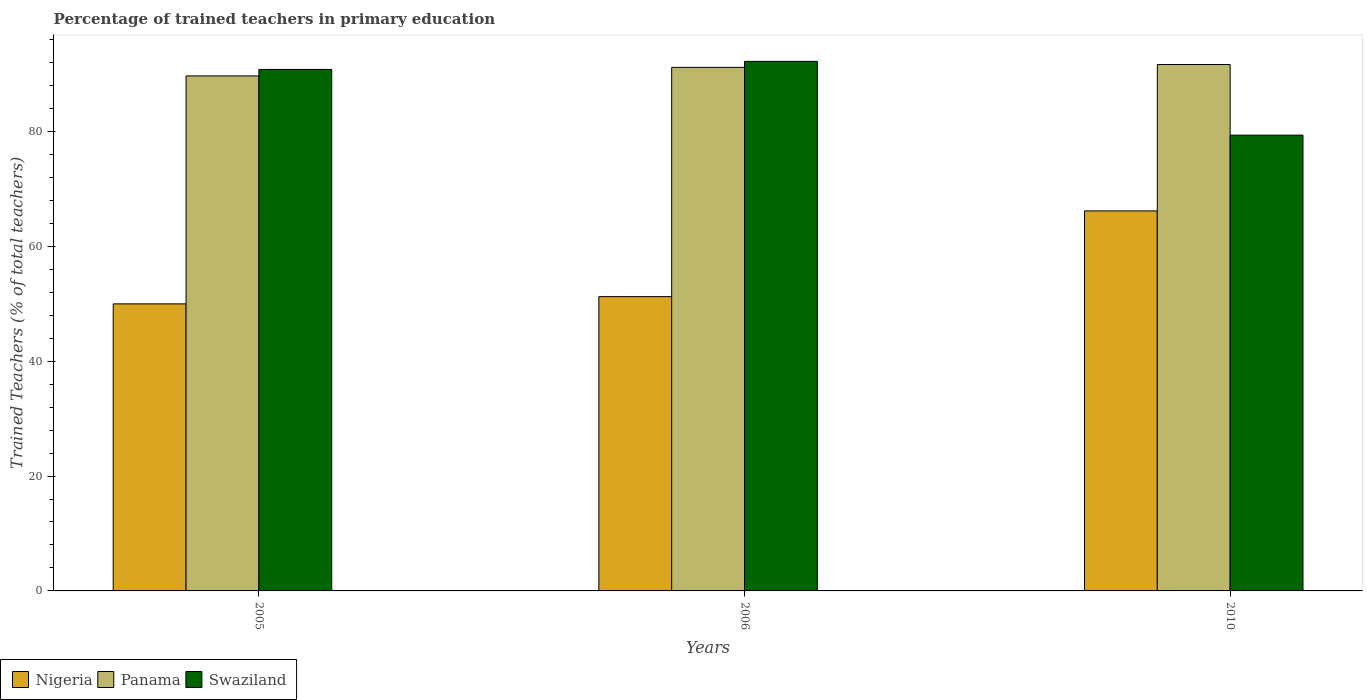How many different coloured bars are there?
Offer a terse response. 3. How many groups of bars are there?
Make the answer very short. 3. Are the number of bars per tick equal to the number of legend labels?
Offer a terse response. Yes. Are the number of bars on each tick of the X-axis equal?
Provide a succinct answer. Yes. How many bars are there on the 2nd tick from the right?
Keep it short and to the point. 3. What is the label of the 2nd group of bars from the left?
Provide a short and direct response. 2006. What is the percentage of trained teachers in Panama in 2005?
Your response must be concise. 89.65. Across all years, what is the maximum percentage of trained teachers in Swaziland?
Offer a very short reply. 92.18. Across all years, what is the minimum percentage of trained teachers in Nigeria?
Provide a short and direct response. 49.97. In which year was the percentage of trained teachers in Panama maximum?
Your answer should be very brief. 2010. What is the total percentage of trained teachers in Panama in the graph?
Provide a short and direct response. 272.41. What is the difference between the percentage of trained teachers in Nigeria in 2005 and that in 2010?
Make the answer very short. -16.18. What is the difference between the percentage of trained teachers in Nigeria in 2005 and the percentage of trained teachers in Panama in 2006?
Give a very brief answer. -41.17. What is the average percentage of trained teachers in Panama per year?
Make the answer very short. 90.8. In the year 2006, what is the difference between the percentage of trained teachers in Nigeria and percentage of trained teachers in Swaziland?
Your response must be concise. -40.96. In how many years, is the percentage of trained teachers in Panama greater than 80 %?
Give a very brief answer. 3. What is the ratio of the percentage of trained teachers in Nigeria in 2006 to that in 2010?
Your response must be concise. 0.77. Is the difference between the percentage of trained teachers in Nigeria in 2005 and 2010 greater than the difference between the percentage of trained teachers in Swaziland in 2005 and 2010?
Make the answer very short. No. What is the difference between the highest and the second highest percentage of trained teachers in Panama?
Provide a short and direct response. 0.5. What is the difference between the highest and the lowest percentage of trained teachers in Swaziland?
Give a very brief answer. 12.84. In how many years, is the percentage of trained teachers in Swaziland greater than the average percentage of trained teachers in Swaziland taken over all years?
Provide a succinct answer. 2. What does the 3rd bar from the left in 2005 represents?
Make the answer very short. Swaziland. What does the 2nd bar from the right in 2010 represents?
Ensure brevity in your answer.  Panama. Are all the bars in the graph horizontal?
Your answer should be very brief. No. What is the difference between two consecutive major ticks on the Y-axis?
Offer a very short reply. 20. Are the values on the major ticks of Y-axis written in scientific E-notation?
Provide a succinct answer. No. How many legend labels are there?
Your response must be concise. 3. How are the legend labels stacked?
Your response must be concise. Horizontal. What is the title of the graph?
Give a very brief answer. Percentage of trained teachers in primary education. What is the label or title of the X-axis?
Your response must be concise. Years. What is the label or title of the Y-axis?
Provide a succinct answer. Trained Teachers (% of total teachers). What is the Trained Teachers (% of total teachers) of Nigeria in 2005?
Give a very brief answer. 49.97. What is the Trained Teachers (% of total teachers) of Panama in 2005?
Your response must be concise. 89.65. What is the Trained Teachers (% of total teachers) in Swaziland in 2005?
Offer a terse response. 90.77. What is the Trained Teachers (% of total teachers) of Nigeria in 2006?
Keep it short and to the point. 51.22. What is the Trained Teachers (% of total teachers) of Panama in 2006?
Ensure brevity in your answer.  91.13. What is the Trained Teachers (% of total teachers) of Swaziland in 2006?
Offer a terse response. 92.18. What is the Trained Teachers (% of total teachers) in Nigeria in 2010?
Your response must be concise. 66.15. What is the Trained Teachers (% of total teachers) of Panama in 2010?
Provide a succinct answer. 91.63. What is the Trained Teachers (% of total teachers) in Swaziland in 2010?
Make the answer very short. 79.34. Across all years, what is the maximum Trained Teachers (% of total teachers) in Nigeria?
Keep it short and to the point. 66.15. Across all years, what is the maximum Trained Teachers (% of total teachers) of Panama?
Make the answer very short. 91.63. Across all years, what is the maximum Trained Teachers (% of total teachers) of Swaziland?
Make the answer very short. 92.18. Across all years, what is the minimum Trained Teachers (% of total teachers) in Nigeria?
Ensure brevity in your answer.  49.97. Across all years, what is the minimum Trained Teachers (% of total teachers) of Panama?
Make the answer very short. 89.65. Across all years, what is the minimum Trained Teachers (% of total teachers) in Swaziland?
Make the answer very short. 79.34. What is the total Trained Teachers (% of total teachers) in Nigeria in the graph?
Ensure brevity in your answer.  167.34. What is the total Trained Teachers (% of total teachers) of Panama in the graph?
Offer a very short reply. 272.41. What is the total Trained Teachers (% of total teachers) in Swaziland in the graph?
Offer a very short reply. 262.29. What is the difference between the Trained Teachers (% of total teachers) in Nigeria in 2005 and that in 2006?
Offer a very short reply. -1.26. What is the difference between the Trained Teachers (% of total teachers) in Panama in 2005 and that in 2006?
Make the answer very short. -1.49. What is the difference between the Trained Teachers (% of total teachers) in Swaziland in 2005 and that in 2006?
Ensure brevity in your answer.  -1.41. What is the difference between the Trained Teachers (% of total teachers) in Nigeria in 2005 and that in 2010?
Your answer should be very brief. -16.18. What is the difference between the Trained Teachers (% of total teachers) of Panama in 2005 and that in 2010?
Keep it short and to the point. -1.98. What is the difference between the Trained Teachers (% of total teachers) of Swaziland in 2005 and that in 2010?
Your answer should be compact. 11.43. What is the difference between the Trained Teachers (% of total teachers) in Nigeria in 2006 and that in 2010?
Provide a short and direct response. -14.92. What is the difference between the Trained Teachers (% of total teachers) in Panama in 2006 and that in 2010?
Your answer should be compact. -0.5. What is the difference between the Trained Teachers (% of total teachers) of Swaziland in 2006 and that in 2010?
Provide a short and direct response. 12.84. What is the difference between the Trained Teachers (% of total teachers) of Nigeria in 2005 and the Trained Teachers (% of total teachers) of Panama in 2006?
Offer a very short reply. -41.17. What is the difference between the Trained Teachers (% of total teachers) in Nigeria in 2005 and the Trained Teachers (% of total teachers) in Swaziland in 2006?
Your answer should be very brief. -42.21. What is the difference between the Trained Teachers (% of total teachers) in Panama in 2005 and the Trained Teachers (% of total teachers) in Swaziland in 2006?
Your answer should be compact. -2.54. What is the difference between the Trained Teachers (% of total teachers) of Nigeria in 2005 and the Trained Teachers (% of total teachers) of Panama in 2010?
Provide a succinct answer. -41.66. What is the difference between the Trained Teachers (% of total teachers) in Nigeria in 2005 and the Trained Teachers (% of total teachers) in Swaziland in 2010?
Make the answer very short. -29.37. What is the difference between the Trained Teachers (% of total teachers) in Panama in 2005 and the Trained Teachers (% of total teachers) in Swaziland in 2010?
Give a very brief answer. 10.31. What is the difference between the Trained Teachers (% of total teachers) in Nigeria in 2006 and the Trained Teachers (% of total teachers) in Panama in 2010?
Make the answer very short. -40.41. What is the difference between the Trained Teachers (% of total teachers) of Nigeria in 2006 and the Trained Teachers (% of total teachers) of Swaziland in 2010?
Your answer should be compact. -28.11. What is the difference between the Trained Teachers (% of total teachers) in Panama in 2006 and the Trained Teachers (% of total teachers) in Swaziland in 2010?
Provide a succinct answer. 11.8. What is the average Trained Teachers (% of total teachers) in Nigeria per year?
Your answer should be compact. 55.78. What is the average Trained Teachers (% of total teachers) of Panama per year?
Your answer should be very brief. 90.8. What is the average Trained Teachers (% of total teachers) in Swaziland per year?
Provide a succinct answer. 87.43. In the year 2005, what is the difference between the Trained Teachers (% of total teachers) in Nigeria and Trained Teachers (% of total teachers) in Panama?
Your response must be concise. -39.68. In the year 2005, what is the difference between the Trained Teachers (% of total teachers) in Nigeria and Trained Teachers (% of total teachers) in Swaziland?
Offer a terse response. -40.81. In the year 2005, what is the difference between the Trained Teachers (% of total teachers) in Panama and Trained Teachers (% of total teachers) in Swaziland?
Provide a succinct answer. -1.13. In the year 2006, what is the difference between the Trained Teachers (% of total teachers) in Nigeria and Trained Teachers (% of total teachers) in Panama?
Your answer should be very brief. -39.91. In the year 2006, what is the difference between the Trained Teachers (% of total teachers) in Nigeria and Trained Teachers (% of total teachers) in Swaziland?
Ensure brevity in your answer.  -40.96. In the year 2006, what is the difference between the Trained Teachers (% of total teachers) of Panama and Trained Teachers (% of total teachers) of Swaziland?
Offer a terse response. -1.05. In the year 2010, what is the difference between the Trained Teachers (% of total teachers) of Nigeria and Trained Teachers (% of total teachers) of Panama?
Your answer should be very brief. -25.48. In the year 2010, what is the difference between the Trained Teachers (% of total teachers) in Nigeria and Trained Teachers (% of total teachers) in Swaziland?
Offer a very short reply. -13.19. In the year 2010, what is the difference between the Trained Teachers (% of total teachers) in Panama and Trained Teachers (% of total teachers) in Swaziland?
Give a very brief answer. 12.29. What is the ratio of the Trained Teachers (% of total teachers) in Nigeria in 2005 to that in 2006?
Offer a very short reply. 0.98. What is the ratio of the Trained Teachers (% of total teachers) of Panama in 2005 to that in 2006?
Provide a succinct answer. 0.98. What is the ratio of the Trained Teachers (% of total teachers) of Swaziland in 2005 to that in 2006?
Your answer should be very brief. 0.98. What is the ratio of the Trained Teachers (% of total teachers) of Nigeria in 2005 to that in 2010?
Offer a very short reply. 0.76. What is the ratio of the Trained Teachers (% of total teachers) in Panama in 2005 to that in 2010?
Give a very brief answer. 0.98. What is the ratio of the Trained Teachers (% of total teachers) of Swaziland in 2005 to that in 2010?
Ensure brevity in your answer.  1.14. What is the ratio of the Trained Teachers (% of total teachers) in Nigeria in 2006 to that in 2010?
Keep it short and to the point. 0.77. What is the ratio of the Trained Teachers (% of total teachers) in Swaziland in 2006 to that in 2010?
Give a very brief answer. 1.16. What is the difference between the highest and the second highest Trained Teachers (% of total teachers) of Nigeria?
Provide a succinct answer. 14.92. What is the difference between the highest and the second highest Trained Teachers (% of total teachers) of Panama?
Your response must be concise. 0.5. What is the difference between the highest and the second highest Trained Teachers (% of total teachers) of Swaziland?
Your answer should be compact. 1.41. What is the difference between the highest and the lowest Trained Teachers (% of total teachers) of Nigeria?
Make the answer very short. 16.18. What is the difference between the highest and the lowest Trained Teachers (% of total teachers) of Panama?
Make the answer very short. 1.98. What is the difference between the highest and the lowest Trained Teachers (% of total teachers) of Swaziland?
Give a very brief answer. 12.84. 